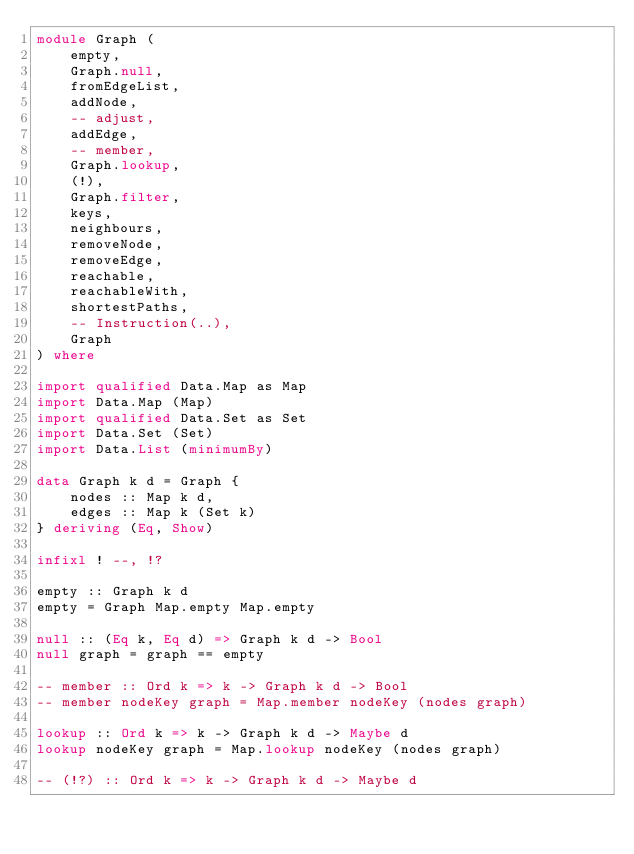<code> <loc_0><loc_0><loc_500><loc_500><_Haskell_>module Graph (
    empty,
    Graph.null,
    fromEdgeList,
    addNode,
    -- adjust,
    addEdge,
    -- member,
    Graph.lookup,
    (!),
    Graph.filter,
    keys,
    neighbours,
    removeNode,
    removeEdge,
    reachable,
    reachableWith,
    shortestPaths,
    -- Instruction(..),
    Graph
) where

import qualified Data.Map as Map
import Data.Map (Map)
import qualified Data.Set as Set
import Data.Set (Set)
import Data.List (minimumBy)

data Graph k d = Graph {
    nodes :: Map k d,
    edges :: Map k (Set k)
} deriving (Eq, Show)

infixl ! --, !?

empty :: Graph k d 
empty = Graph Map.empty Map.empty

null :: (Eq k, Eq d) => Graph k d -> Bool
null graph = graph == empty

-- member :: Ord k => k -> Graph k d -> Bool 
-- member nodeKey graph = Map.member nodeKey (nodes graph)

lookup :: Ord k => k -> Graph k d -> Maybe d
lookup nodeKey graph = Map.lookup nodeKey (nodes graph)

-- (!?) :: Ord k => k -> Graph k d -> Maybe d</code> 